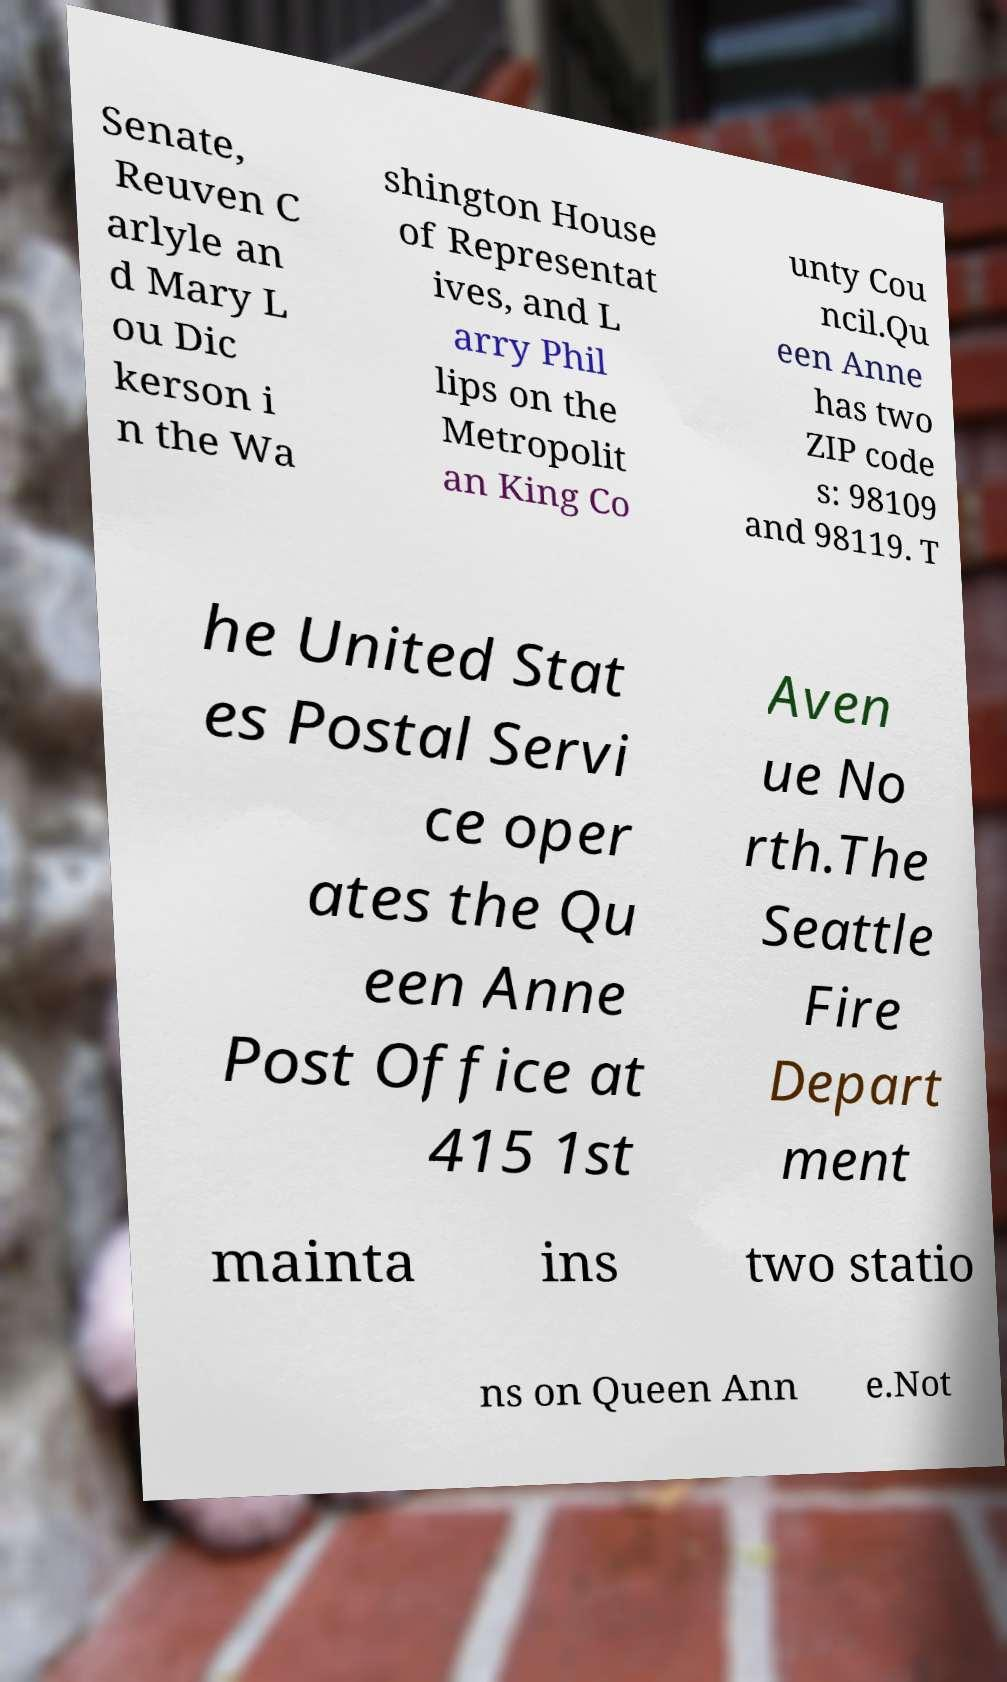I need the written content from this picture converted into text. Can you do that? Senate, Reuven C arlyle an d Mary L ou Dic kerson i n the Wa shington House of Representat ives, and L arry Phil lips on the Metropolit an King Co unty Cou ncil.Qu een Anne has two ZIP code s: 98109 and 98119. T he United Stat es Postal Servi ce oper ates the Qu een Anne Post Office at 415 1st Aven ue No rth.The Seattle Fire Depart ment mainta ins two statio ns on Queen Ann e.Not 